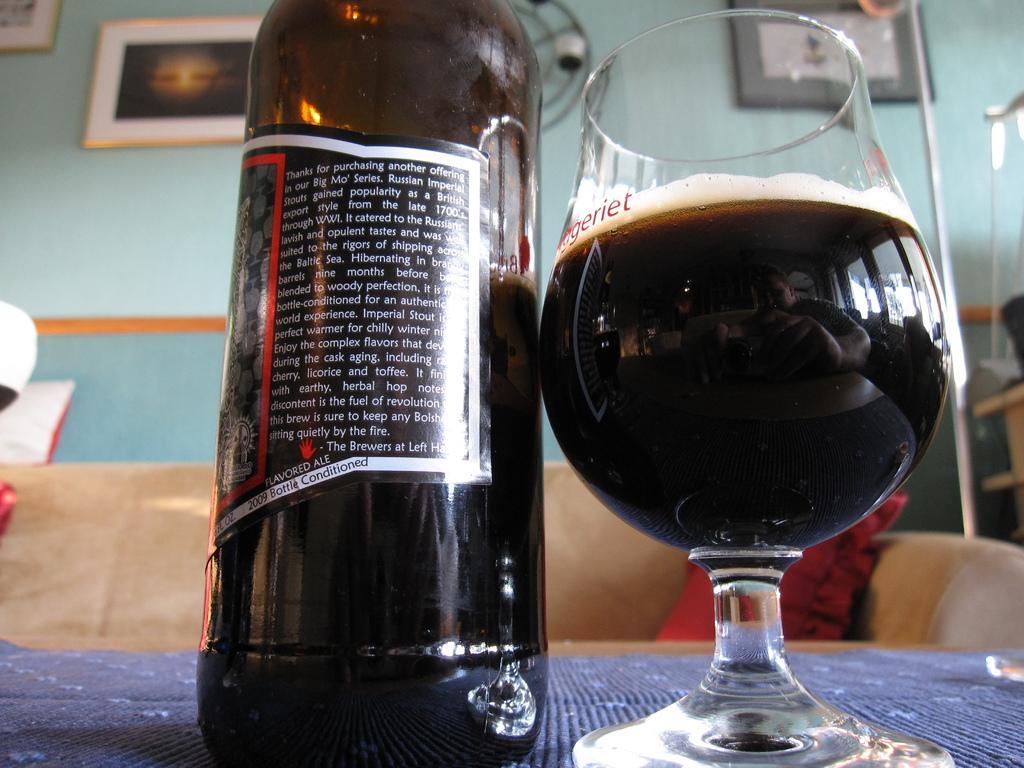Describe this image in one or two sentences. In this picture we can see bottle with sticker to it aside to this we have a glass with drink in it placed on a table and in background we can see sofa with pillows on it, wall with frames. 